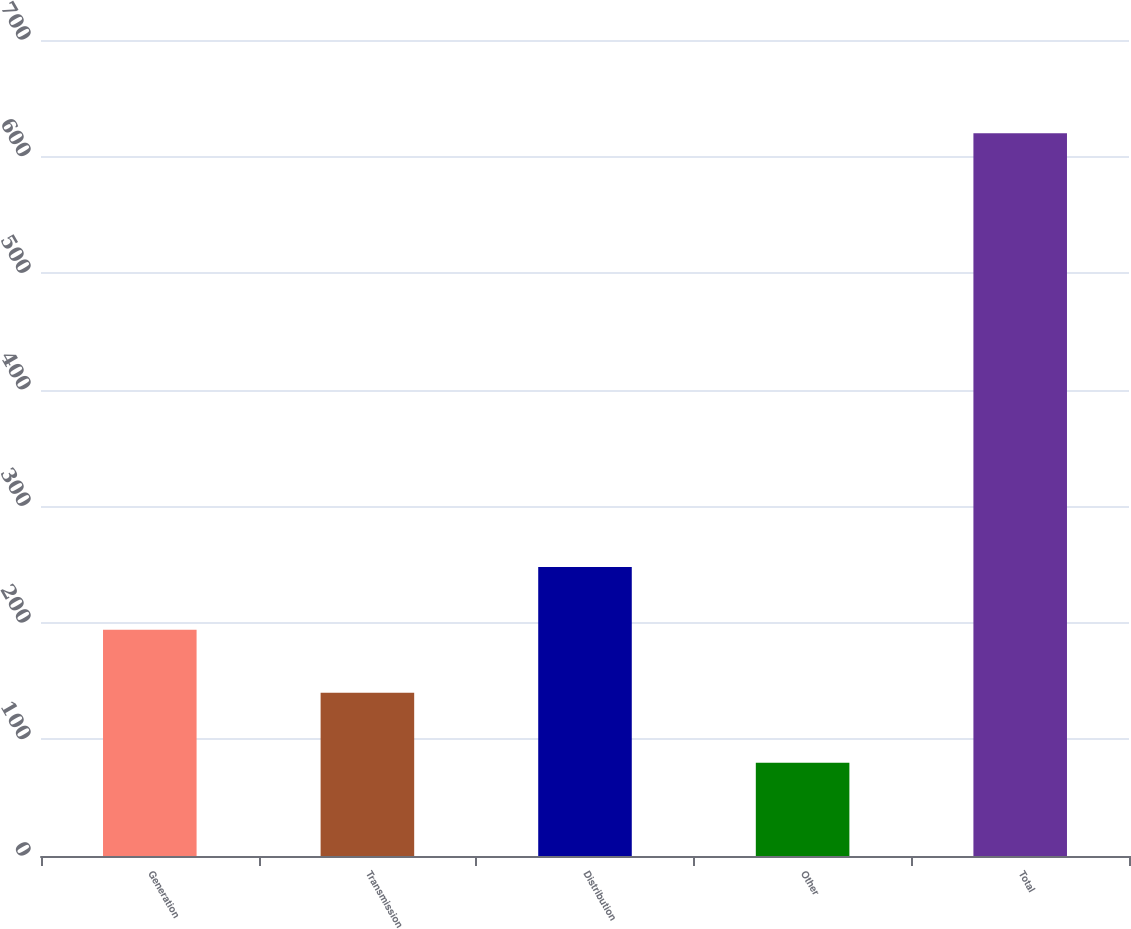Convert chart to OTSL. <chart><loc_0><loc_0><loc_500><loc_500><bar_chart><fcel>Generation<fcel>Transmission<fcel>Distribution<fcel>Other<fcel>Total<nl><fcel>194<fcel>140<fcel>248<fcel>80<fcel>620<nl></chart> 